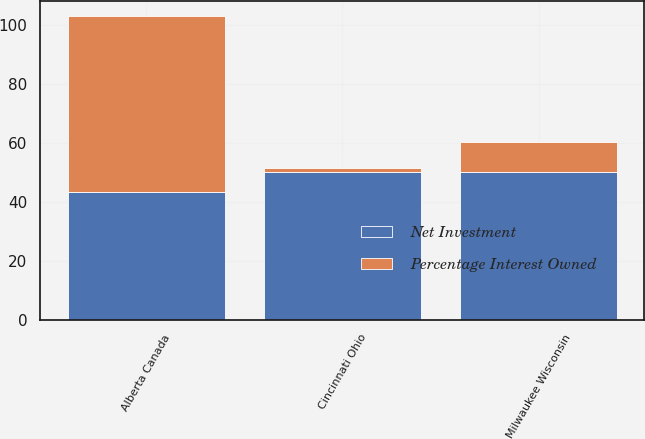Convert chart. <chart><loc_0><loc_0><loc_500><loc_500><stacked_bar_chart><ecel><fcel>Milwaukee Wisconsin<fcel>Alberta Canada<fcel>Cincinnati Ohio<nl><fcel>Percentage Interest Owned<fcel>10.4<fcel>59.7<fcel>1.3<nl><fcel>Net Investment<fcel>50<fcel>43.37<fcel>50<nl></chart> 